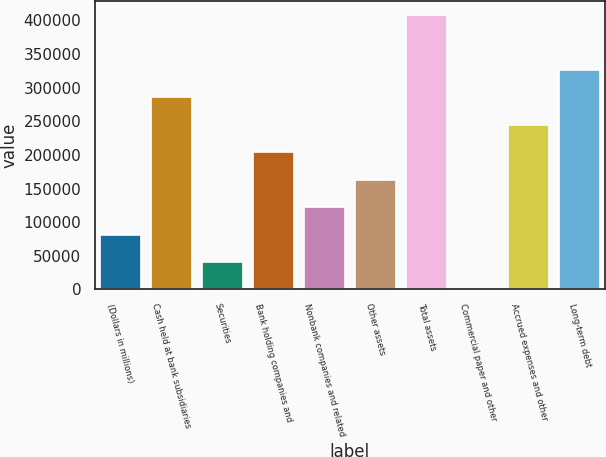<chart> <loc_0><loc_0><loc_500><loc_500><bar_chart><fcel>(Dollars in millions)<fcel>Cash held at bank subsidiaries<fcel>Securities<fcel>Bank holding companies and<fcel>Nonbank companies and related<fcel>Other assets<fcel>Total assets<fcel>Commercial paper and other<fcel>Accrued expenses and other<fcel>Long-term debt<nl><fcel>81568.6<fcel>285240<fcel>40834.3<fcel>203772<fcel>122303<fcel>163037<fcel>407443<fcel>100<fcel>244506<fcel>325974<nl></chart> 